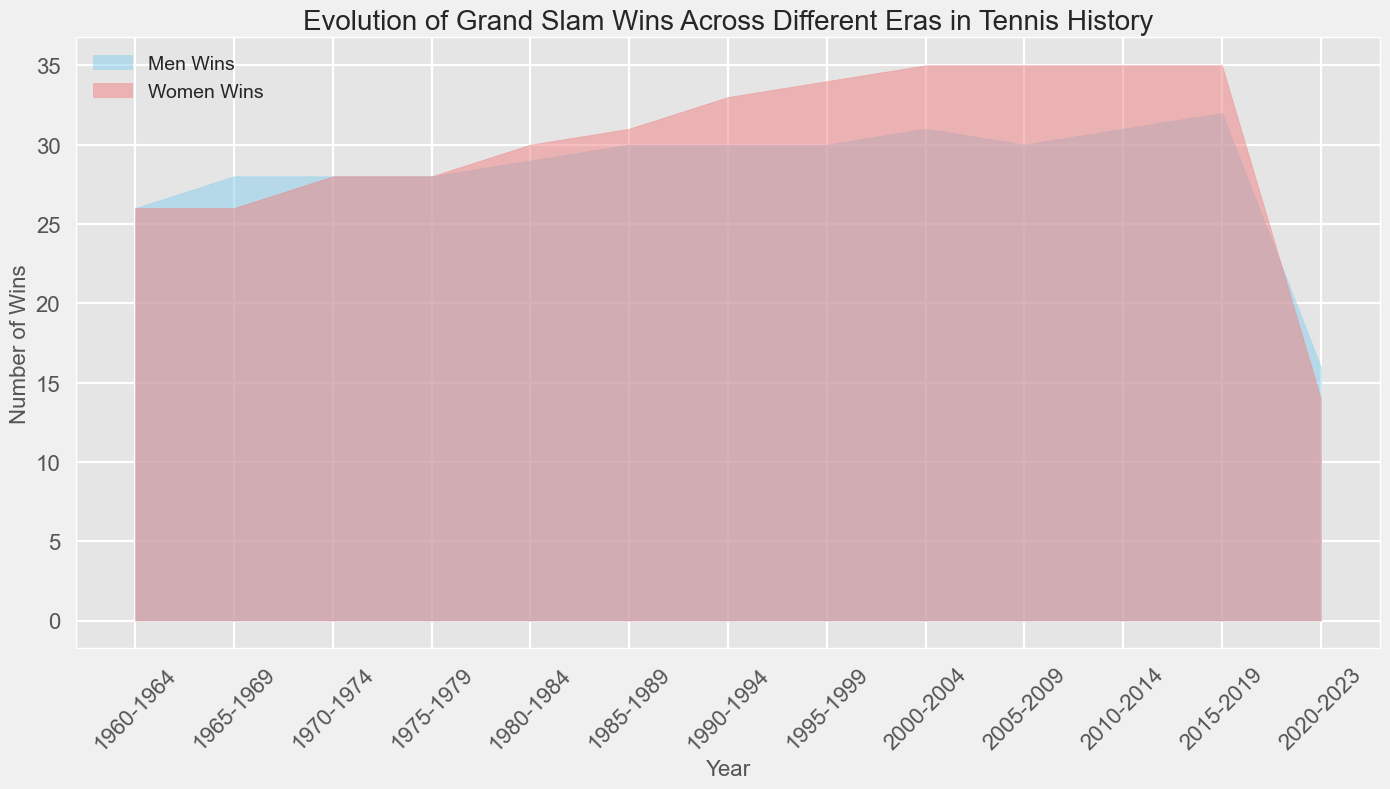Which era shows an equal number of Grand Slam wins for both men and women? The era 1960-1964 shows the same number of Grand Slam wins for both men and women. This can be seen where the areas representing men's wins and women's wins overlap exactly.
Answer: 1960-1964 From the era of 2015-2019, did men or women have more Grand Slam wins? From the visual representation, the shaded area for women (in light coral) overlaps the area for men (in sky blue), extending slightly higher than the men's area, indicating that women had more Grand Slam wins during this period.
Answer: Women Which year range shows a sudden drop in Grand Slam wins for both men and women? The era 2020-2023 shows a significant drop in wins for both men and women compared to the previous eras, as indicated by the smaller shaded areas for both men's and women's wins.
Answer: 2020-2023 In which era did men's Grand Slam wins surpass women's wins for the first time? The 2015-2019 period is when men's Grand Slam wins surpassed women's wins, as indicated by the sky blue area extending higher than the light coral area.
Answer: 2015-2019 How many Grand Slam wins do men and women have in total from the era 2000-2004? Men have 31 wins and women have 31 wins in the era 2000-2004. By summing both, we find the total number of wins: 31 + 31 = 62.
Answer: 62 During which era do both men and women have the highest combined number of wins? In the visual representation, the era 1995-1999 shows the highest cumulative shaded areas for both men and women. The combined number of men's and women's wins is 34 + 34 = 68.
Answer: 1995-1999 Compare the growth rate in Grand Slam wins from 1960-1964 to 1985-1989 for men and women. From 1960-1964, men had 26 wins, increasing to 30 wins from 1985-1989. Women had 26 wins in 1960-1964, increasing to 31 wins by 1985-1989. The difference in growth: For men = 30 - 26 = 4; For women = 31 - 26 = 5. Therefore, women had a slightly higher growth rate than men in that period.
Answer: Women Between 1970-1974 and 1980-1984, which group had greater consistency in the number of Grand Slam wins? Both men and women had nearly identical growths in wins: Men increased from 28 to 29 while women increased from 28 to 30. However, the smaller change in men's wins (only 1) indicates that men had greater consistency compared to women (2).
Answer: Men 